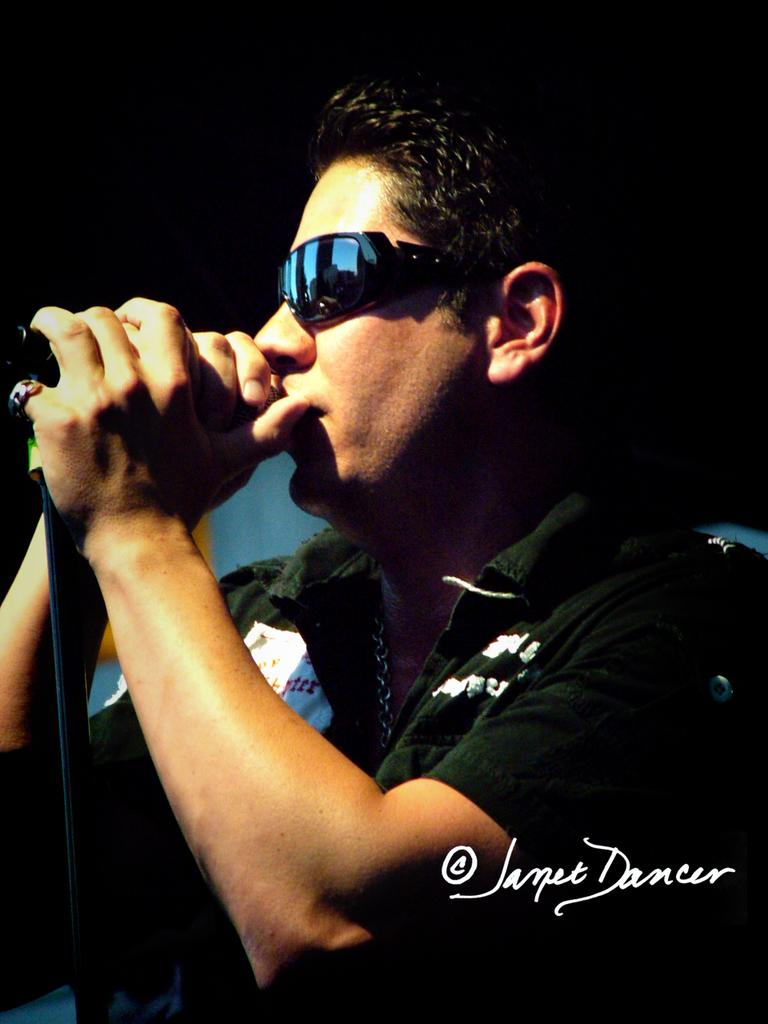What is the man in the picture doing? The man is singing. What is the man holding while singing? The man is holding a microphone. What is the man wearing on his upper body? The man is wearing a black color T-shirt. What device is the man wearing on his eyes? There is a Google Glass-like device on his eyes. What type of garden can be seen in the background of the image? There is no garden visible in the image. 